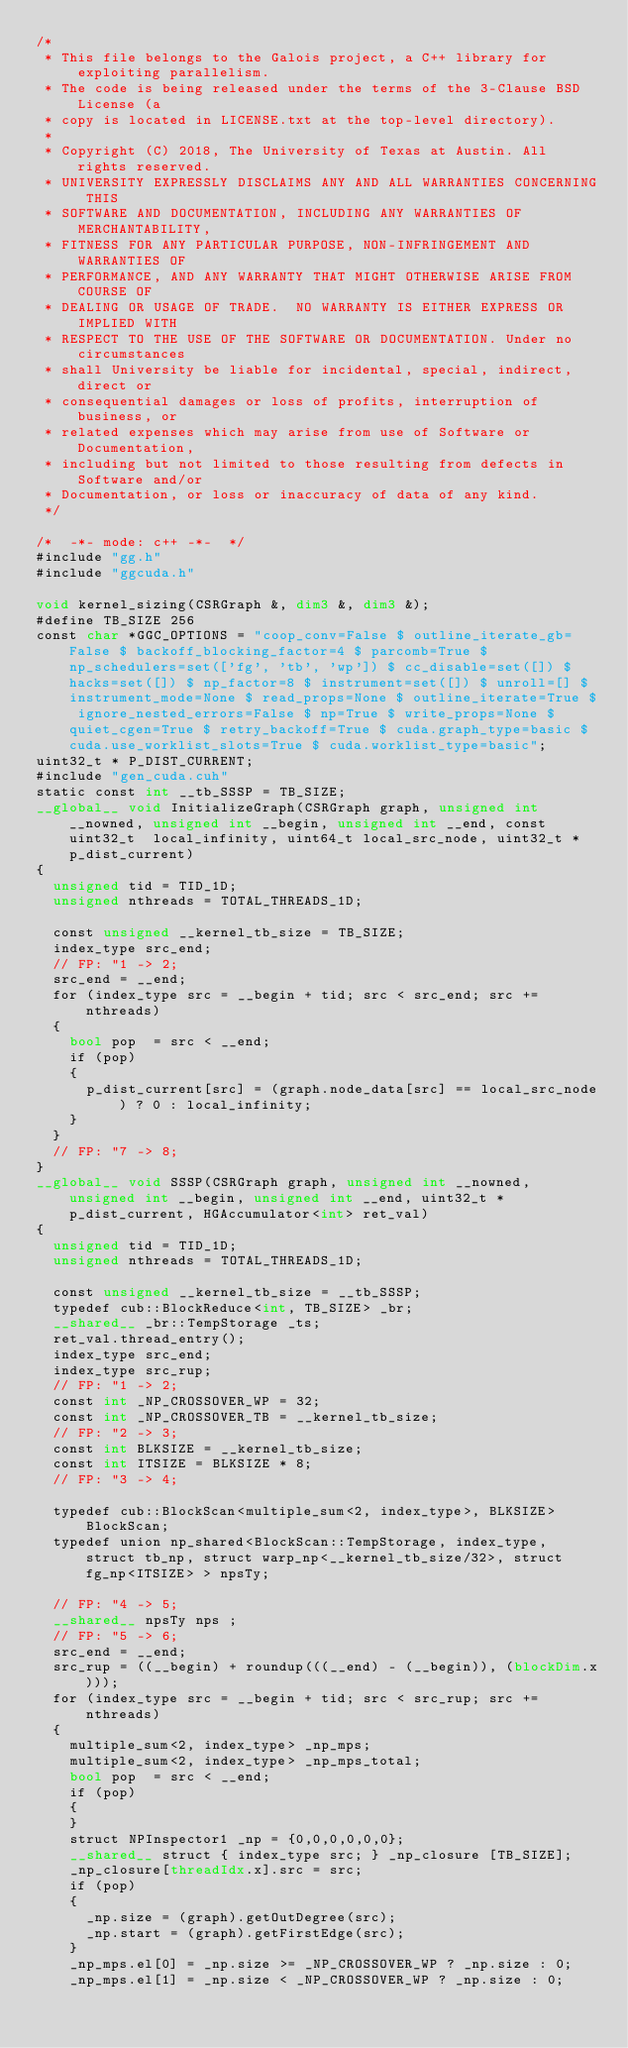<code> <loc_0><loc_0><loc_500><loc_500><_Cuda_>/*
 * This file belongs to the Galois project, a C++ library for exploiting parallelism.
 * The code is being released under the terms of the 3-Clause BSD License (a
 * copy is located in LICENSE.txt at the top-level directory).
 *
 * Copyright (C) 2018, The University of Texas at Austin. All rights reserved.
 * UNIVERSITY EXPRESSLY DISCLAIMS ANY AND ALL WARRANTIES CONCERNING THIS
 * SOFTWARE AND DOCUMENTATION, INCLUDING ANY WARRANTIES OF MERCHANTABILITY,
 * FITNESS FOR ANY PARTICULAR PURPOSE, NON-INFRINGEMENT AND WARRANTIES OF
 * PERFORMANCE, AND ANY WARRANTY THAT MIGHT OTHERWISE ARISE FROM COURSE OF
 * DEALING OR USAGE OF TRADE.  NO WARRANTY IS EITHER EXPRESS OR IMPLIED WITH
 * RESPECT TO THE USE OF THE SOFTWARE OR DOCUMENTATION. Under no circumstances
 * shall University be liable for incidental, special, indirect, direct or
 * consequential damages or loss of profits, interruption of business, or
 * related expenses which may arise from use of Software or Documentation,
 * including but not limited to those resulting from defects in Software and/or
 * Documentation, or loss or inaccuracy of data of any kind.
 */

/*  -*- mode: c++ -*-  */
#include "gg.h"
#include "ggcuda.h"

void kernel_sizing(CSRGraph &, dim3 &, dim3 &);
#define TB_SIZE 256
const char *GGC_OPTIONS = "coop_conv=False $ outline_iterate_gb=False $ backoff_blocking_factor=4 $ parcomb=True $ np_schedulers=set(['fg', 'tb', 'wp']) $ cc_disable=set([]) $ hacks=set([]) $ np_factor=8 $ instrument=set([]) $ unroll=[] $ instrument_mode=None $ read_props=None $ outline_iterate=True $ ignore_nested_errors=False $ np=True $ write_props=None $ quiet_cgen=True $ retry_backoff=True $ cuda.graph_type=basic $ cuda.use_worklist_slots=True $ cuda.worklist_type=basic";
uint32_t * P_DIST_CURRENT;
#include "gen_cuda.cuh"
static const int __tb_SSSP = TB_SIZE;
__global__ void InitializeGraph(CSRGraph graph, unsigned int __nowned, unsigned int __begin, unsigned int __end, const uint32_t  local_infinity, uint64_t local_src_node, uint32_t * p_dist_current)
{
  unsigned tid = TID_1D;
  unsigned nthreads = TOTAL_THREADS_1D;

  const unsigned __kernel_tb_size = TB_SIZE;
  index_type src_end;
  // FP: "1 -> 2;
  src_end = __end;
  for (index_type src = __begin + tid; src < src_end; src += nthreads)
  {
    bool pop  = src < __end;
    if (pop)
    {
      p_dist_current[src] = (graph.node_data[src] == local_src_node) ? 0 : local_infinity;
    }
  }
  // FP: "7 -> 8;
}
__global__ void SSSP(CSRGraph graph, unsigned int __nowned, unsigned int __begin, unsigned int __end, uint32_t * p_dist_current, HGAccumulator<int> ret_val)
{
  unsigned tid = TID_1D;
  unsigned nthreads = TOTAL_THREADS_1D;

  const unsigned __kernel_tb_size = __tb_SSSP;
  typedef cub::BlockReduce<int, TB_SIZE> _br;
  __shared__ _br::TempStorage _ts;
  ret_val.thread_entry();
  index_type src_end;
  index_type src_rup;
  // FP: "1 -> 2;
  const int _NP_CROSSOVER_WP = 32;
  const int _NP_CROSSOVER_TB = __kernel_tb_size;
  // FP: "2 -> 3;
  const int BLKSIZE = __kernel_tb_size;
  const int ITSIZE = BLKSIZE * 8;
  // FP: "3 -> 4;

  typedef cub::BlockScan<multiple_sum<2, index_type>, BLKSIZE> BlockScan;
  typedef union np_shared<BlockScan::TempStorage, index_type, struct tb_np, struct warp_np<__kernel_tb_size/32>, struct fg_np<ITSIZE> > npsTy;

  // FP: "4 -> 5;
  __shared__ npsTy nps ;
  // FP: "5 -> 6;
  src_end = __end;
  src_rup = ((__begin) + roundup(((__end) - (__begin)), (blockDim.x)));
  for (index_type src = __begin + tid; src < src_rup; src += nthreads)
  {
    multiple_sum<2, index_type> _np_mps;
    multiple_sum<2, index_type> _np_mps_total;
    bool pop  = src < __end;
    if (pop)
    {
    }
    struct NPInspector1 _np = {0,0,0,0,0,0};
    __shared__ struct { index_type src; } _np_closure [TB_SIZE];
    _np_closure[threadIdx.x].src = src;
    if (pop)
    {
      _np.size = (graph).getOutDegree(src);
      _np.start = (graph).getFirstEdge(src);
    }
    _np_mps.el[0] = _np.size >= _NP_CROSSOVER_WP ? _np.size : 0;
    _np_mps.el[1] = _np.size < _NP_CROSSOVER_WP ? _np.size : 0;</code> 